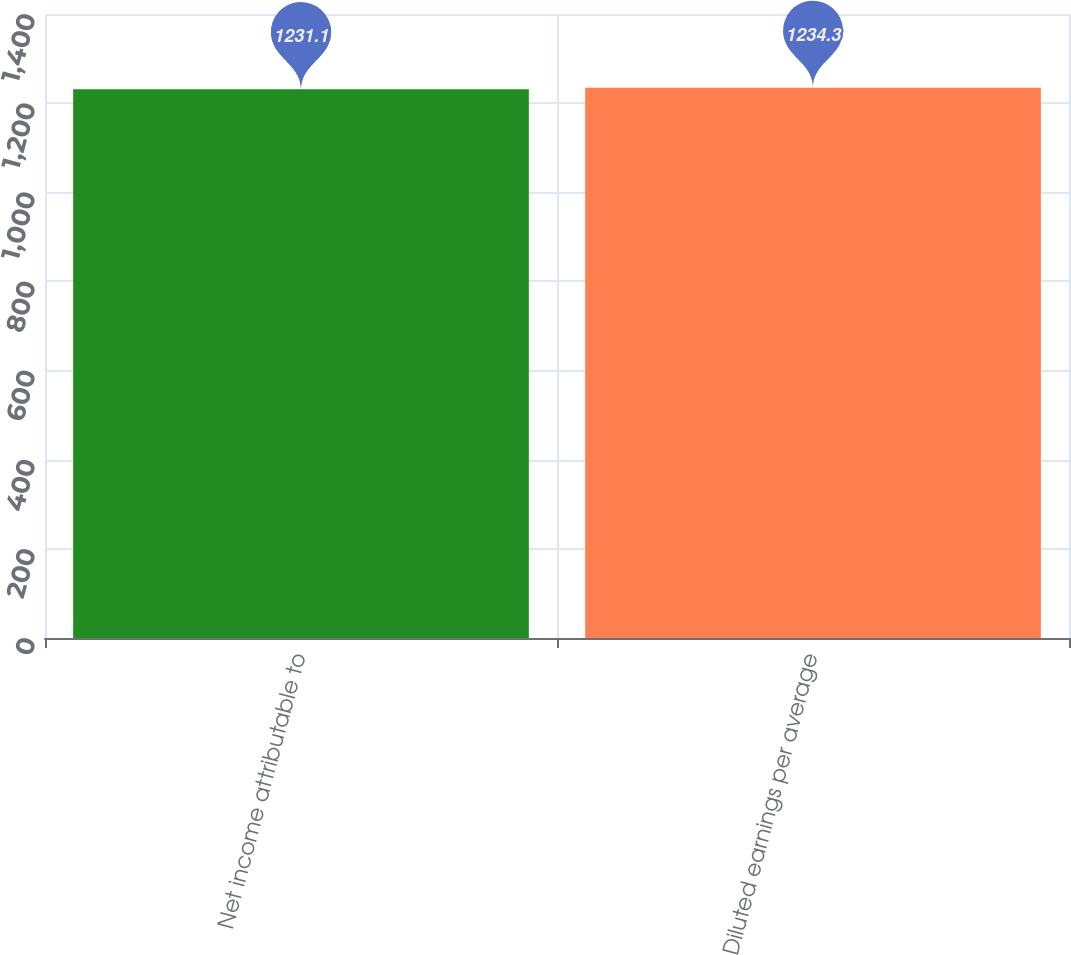<chart> <loc_0><loc_0><loc_500><loc_500><bar_chart><fcel>Net income attributable to<fcel>Diluted earnings per average<nl><fcel>1231.1<fcel>1234.3<nl></chart> 